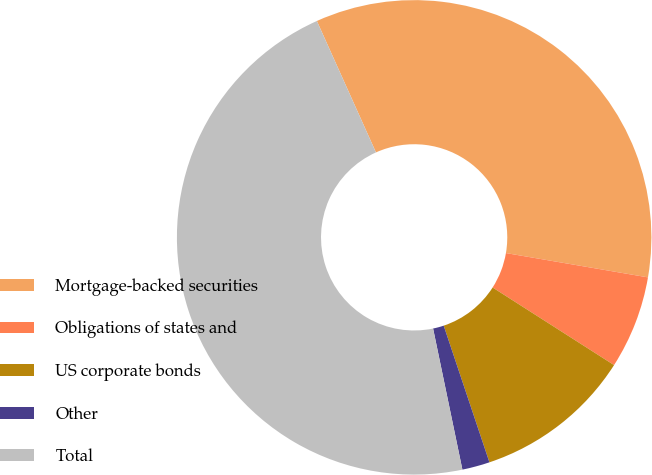<chart> <loc_0><loc_0><loc_500><loc_500><pie_chart><fcel>Mortgage-backed securities<fcel>Obligations of states and<fcel>US corporate bonds<fcel>Other<fcel>Total<nl><fcel>34.42%<fcel>6.35%<fcel>10.81%<fcel>1.88%<fcel>46.53%<nl></chart> 